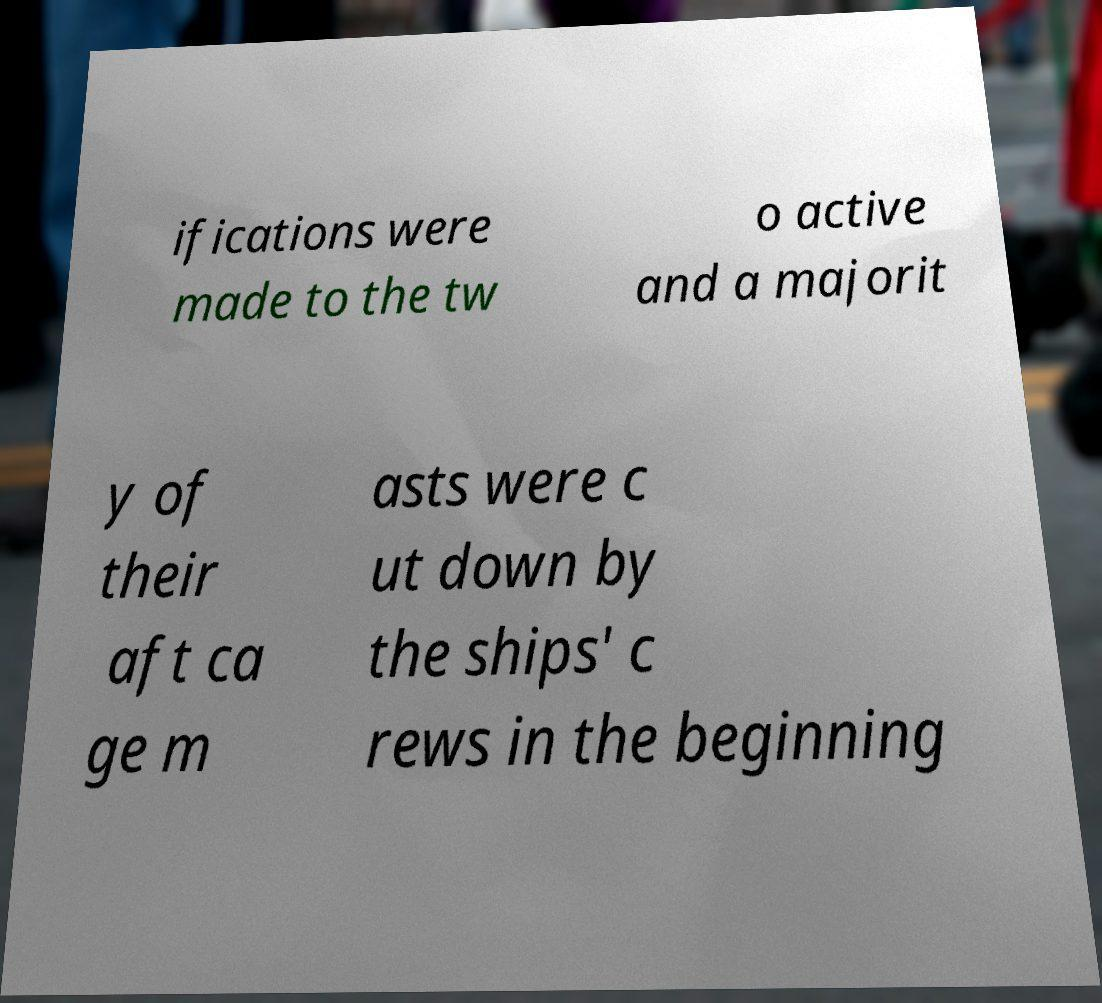Please read and relay the text visible in this image. What does it say? ifications were made to the tw o active and a majorit y of their aft ca ge m asts were c ut down by the ships' c rews in the beginning 